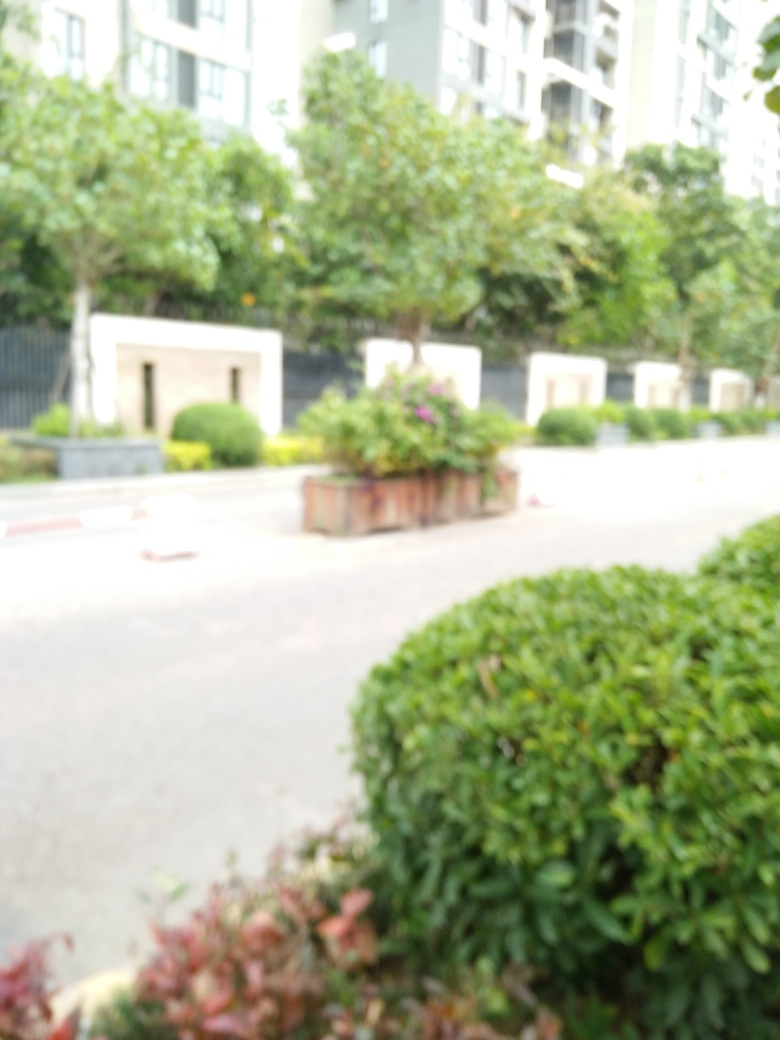Can you tell what might have caused the focusing issues in this photo? The focusing issues could be due to several factors: the camera might have been set to the wrong focus mode, there could have been movement either from the camera or within the scene during exposure, or environmental conditions such as low light might have made it difficult for the camera's autofocus to function accurately. 